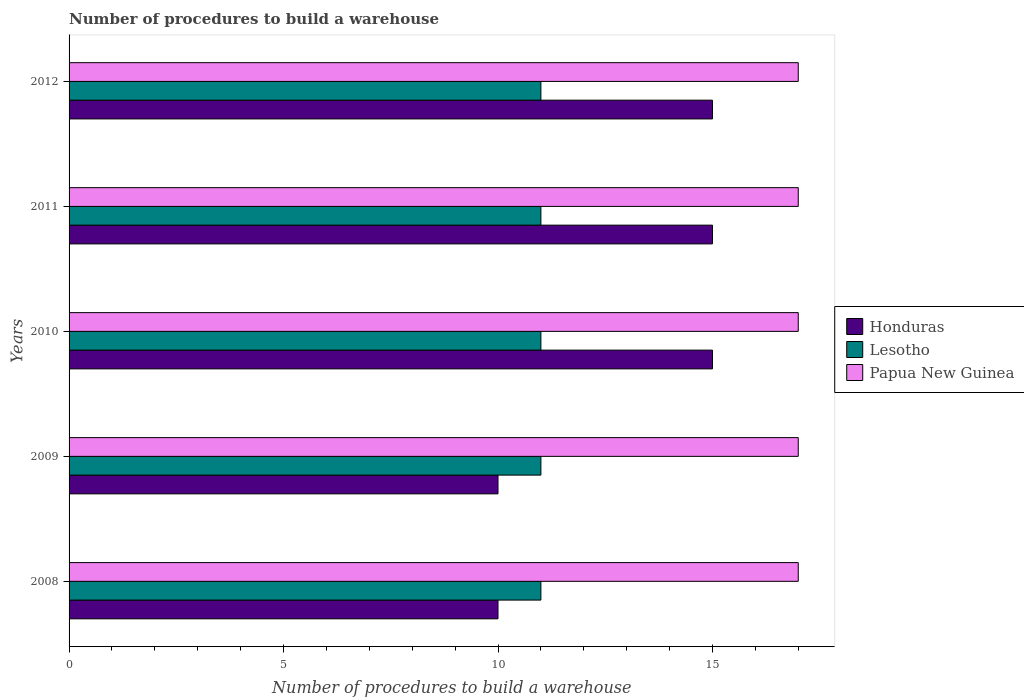How many groups of bars are there?
Ensure brevity in your answer.  5. Are the number of bars per tick equal to the number of legend labels?
Your answer should be very brief. Yes. What is the label of the 2nd group of bars from the top?
Provide a short and direct response. 2011. In how many cases, is the number of bars for a given year not equal to the number of legend labels?
Offer a terse response. 0. What is the number of procedures to build a warehouse in in Honduras in 2011?
Make the answer very short. 15. Across all years, what is the maximum number of procedures to build a warehouse in in Honduras?
Provide a short and direct response. 15. Across all years, what is the minimum number of procedures to build a warehouse in in Lesotho?
Provide a succinct answer. 11. In which year was the number of procedures to build a warehouse in in Papua New Guinea maximum?
Ensure brevity in your answer.  2008. What is the total number of procedures to build a warehouse in in Lesotho in the graph?
Offer a very short reply. 55. What is the difference between the number of procedures to build a warehouse in in Lesotho in 2008 and that in 2012?
Offer a very short reply. 0. What is the difference between the number of procedures to build a warehouse in in Lesotho in 2009 and the number of procedures to build a warehouse in in Papua New Guinea in 2011?
Provide a succinct answer. -6. In the year 2011, what is the difference between the number of procedures to build a warehouse in in Lesotho and number of procedures to build a warehouse in in Honduras?
Give a very brief answer. -4. In how many years, is the number of procedures to build a warehouse in in Papua New Guinea greater than 9 ?
Provide a succinct answer. 5. Is the number of procedures to build a warehouse in in Lesotho in 2010 less than that in 2011?
Provide a succinct answer. No. Is the difference between the number of procedures to build a warehouse in in Lesotho in 2010 and 2011 greater than the difference between the number of procedures to build a warehouse in in Honduras in 2010 and 2011?
Provide a short and direct response. No. What is the difference between the highest and the lowest number of procedures to build a warehouse in in Lesotho?
Your answer should be very brief. 0. Is the sum of the number of procedures to build a warehouse in in Papua New Guinea in 2008 and 2009 greater than the maximum number of procedures to build a warehouse in in Honduras across all years?
Your response must be concise. Yes. What does the 1st bar from the top in 2012 represents?
Your answer should be very brief. Papua New Guinea. What does the 2nd bar from the bottom in 2010 represents?
Your answer should be very brief. Lesotho. How many years are there in the graph?
Provide a succinct answer. 5. Are the values on the major ticks of X-axis written in scientific E-notation?
Your response must be concise. No. Does the graph contain any zero values?
Offer a very short reply. No. Where does the legend appear in the graph?
Ensure brevity in your answer.  Center right. What is the title of the graph?
Your answer should be very brief. Number of procedures to build a warehouse. What is the label or title of the X-axis?
Your response must be concise. Number of procedures to build a warehouse. What is the label or title of the Y-axis?
Provide a succinct answer. Years. What is the Number of procedures to build a warehouse of Papua New Guinea in 2008?
Offer a very short reply. 17. What is the Number of procedures to build a warehouse of Honduras in 2009?
Your answer should be compact. 10. What is the Number of procedures to build a warehouse of Lesotho in 2010?
Offer a terse response. 11. What is the Number of procedures to build a warehouse in Papua New Guinea in 2010?
Provide a succinct answer. 17. What is the Number of procedures to build a warehouse in Honduras in 2011?
Offer a very short reply. 15. What is the Number of procedures to build a warehouse of Lesotho in 2011?
Offer a terse response. 11. What is the Number of procedures to build a warehouse of Papua New Guinea in 2012?
Make the answer very short. 17. Across all years, what is the maximum Number of procedures to build a warehouse in Lesotho?
Your answer should be very brief. 11. Across all years, what is the maximum Number of procedures to build a warehouse in Papua New Guinea?
Offer a terse response. 17. Across all years, what is the minimum Number of procedures to build a warehouse in Lesotho?
Your response must be concise. 11. What is the total Number of procedures to build a warehouse in Honduras in the graph?
Offer a terse response. 65. What is the difference between the Number of procedures to build a warehouse in Lesotho in 2008 and that in 2009?
Your answer should be very brief. 0. What is the difference between the Number of procedures to build a warehouse of Papua New Guinea in 2008 and that in 2009?
Your answer should be compact. 0. What is the difference between the Number of procedures to build a warehouse of Honduras in 2008 and that in 2010?
Give a very brief answer. -5. What is the difference between the Number of procedures to build a warehouse in Papua New Guinea in 2008 and that in 2010?
Make the answer very short. 0. What is the difference between the Number of procedures to build a warehouse in Honduras in 2008 and that in 2011?
Your answer should be compact. -5. What is the difference between the Number of procedures to build a warehouse in Lesotho in 2008 and that in 2011?
Offer a very short reply. 0. What is the difference between the Number of procedures to build a warehouse in Papua New Guinea in 2008 and that in 2011?
Ensure brevity in your answer.  0. What is the difference between the Number of procedures to build a warehouse of Honduras in 2009 and that in 2010?
Make the answer very short. -5. What is the difference between the Number of procedures to build a warehouse in Papua New Guinea in 2009 and that in 2012?
Provide a short and direct response. 0. What is the difference between the Number of procedures to build a warehouse in Lesotho in 2010 and that in 2012?
Offer a very short reply. 0. What is the difference between the Number of procedures to build a warehouse in Papua New Guinea in 2010 and that in 2012?
Give a very brief answer. 0. What is the difference between the Number of procedures to build a warehouse in Lesotho in 2011 and that in 2012?
Offer a very short reply. 0. What is the difference between the Number of procedures to build a warehouse of Papua New Guinea in 2011 and that in 2012?
Make the answer very short. 0. What is the difference between the Number of procedures to build a warehouse in Honduras in 2008 and the Number of procedures to build a warehouse in Lesotho in 2009?
Your answer should be very brief. -1. What is the difference between the Number of procedures to build a warehouse of Honduras in 2008 and the Number of procedures to build a warehouse of Papua New Guinea in 2009?
Offer a very short reply. -7. What is the difference between the Number of procedures to build a warehouse of Honduras in 2008 and the Number of procedures to build a warehouse of Papua New Guinea in 2010?
Your answer should be very brief. -7. What is the difference between the Number of procedures to build a warehouse of Lesotho in 2008 and the Number of procedures to build a warehouse of Papua New Guinea in 2010?
Your answer should be compact. -6. What is the difference between the Number of procedures to build a warehouse of Honduras in 2008 and the Number of procedures to build a warehouse of Lesotho in 2011?
Your answer should be very brief. -1. What is the difference between the Number of procedures to build a warehouse in Honduras in 2008 and the Number of procedures to build a warehouse in Papua New Guinea in 2011?
Provide a short and direct response. -7. What is the difference between the Number of procedures to build a warehouse in Honduras in 2009 and the Number of procedures to build a warehouse in Papua New Guinea in 2010?
Provide a succinct answer. -7. What is the difference between the Number of procedures to build a warehouse of Lesotho in 2009 and the Number of procedures to build a warehouse of Papua New Guinea in 2010?
Make the answer very short. -6. What is the difference between the Number of procedures to build a warehouse of Honduras in 2009 and the Number of procedures to build a warehouse of Lesotho in 2011?
Offer a very short reply. -1. What is the difference between the Number of procedures to build a warehouse of Honduras in 2009 and the Number of procedures to build a warehouse of Papua New Guinea in 2011?
Ensure brevity in your answer.  -7. What is the difference between the Number of procedures to build a warehouse in Honduras in 2009 and the Number of procedures to build a warehouse in Lesotho in 2012?
Your answer should be compact. -1. What is the difference between the Number of procedures to build a warehouse in Lesotho in 2009 and the Number of procedures to build a warehouse in Papua New Guinea in 2012?
Make the answer very short. -6. What is the difference between the Number of procedures to build a warehouse in Honduras in 2010 and the Number of procedures to build a warehouse in Lesotho in 2012?
Keep it short and to the point. 4. What is the difference between the Number of procedures to build a warehouse in Honduras in 2011 and the Number of procedures to build a warehouse in Lesotho in 2012?
Your answer should be compact. 4. What is the difference between the Number of procedures to build a warehouse of Lesotho in 2011 and the Number of procedures to build a warehouse of Papua New Guinea in 2012?
Offer a very short reply. -6. What is the average Number of procedures to build a warehouse in Honduras per year?
Provide a short and direct response. 13. In the year 2008, what is the difference between the Number of procedures to build a warehouse in Honduras and Number of procedures to build a warehouse in Papua New Guinea?
Your answer should be very brief. -7. In the year 2009, what is the difference between the Number of procedures to build a warehouse in Honduras and Number of procedures to build a warehouse in Lesotho?
Make the answer very short. -1. In the year 2010, what is the difference between the Number of procedures to build a warehouse of Honduras and Number of procedures to build a warehouse of Lesotho?
Your answer should be very brief. 4. In the year 2010, what is the difference between the Number of procedures to build a warehouse of Lesotho and Number of procedures to build a warehouse of Papua New Guinea?
Your response must be concise. -6. In the year 2011, what is the difference between the Number of procedures to build a warehouse in Honduras and Number of procedures to build a warehouse in Lesotho?
Ensure brevity in your answer.  4. In the year 2011, what is the difference between the Number of procedures to build a warehouse of Honduras and Number of procedures to build a warehouse of Papua New Guinea?
Make the answer very short. -2. In the year 2012, what is the difference between the Number of procedures to build a warehouse of Honduras and Number of procedures to build a warehouse of Papua New Guinea?
Provide a short and direct response. -2. In the year 2012, what is the difference between the Number of procedures to build a warehouse in Lesotho and Number of procedures to build a warehouse in Papua New Guinea?
Keep it short and to the point. -6. What is the ratio of the Number of procedures to build a warehouse of Honduras in 2008 to that in 2009?
Ensure brevity in your answer.  1. What is the ratio of the Number of procedures to build a warehouse in Papua New Guinea in 2008 to that in 2009?
Your answer should be very brief. 1. What is the ratio of the Number of procedures to build a warehouse in Lesotho in 2008 to that in 2010?
Give a very brief answer. 1. What is the ratio of the Number of procedures to build a warehouse of Papua New Guinea in 2008 to that in 2010?
Your response must be concise. 1. What is the ratio of the Number of procedures to build a warehouse in Honduras in 2008 to that in 2011?
Make the answer very short. 0.67. What is the ratio of the Number of procedures to build a warehouse of Papua New Guinea in 2008 to that in 2011?
Offer a very short reply. 1. What is the ratio of the Number of procedures to build a warehouse of Lesotho in 2008 to that in 2012?
Your answer should be very brief. 1. What is the ratio of the Number of procedures to build a warehouse of Honduras in 2009 to that in 2010?
Offer a terse response. 0.67. What is the ratio of the Number of procedures to build a warehouse of Lesotho in 2009 to that in 2010?
Make the answer very short. 1. What is the ratio of the Number of procedures to build a warehouse of Papua New Guinea in 2009 to that in 2011?
Keep it short and to the point. 1. What is the ratio of the Number of procedures to build a warehouse of Papua New Guinea in 2009 to that in 2012?
Your answer should be compact. 1. What is the ratio of the Number of procedures to build a warehouse in Honduras in 2010 to that in 2011?
Provide a short and direct response. 1. What is the ratio of the Number of procedures to build a warehouse of Honduras in 2010 to that in 2012?
Your answer should be very brief. 1. What is the ratio of the Number of procedures to build a warehouse of Lesotho in 2010 to that in 2012?
Your response must be concise. 1. What is the ratio of the Number of procedures to build a warehouse of Papua New Guinea in 2010 to that in 2012?
Ensure brevity in your answer.  1. What is the ratio of the Number of procedures to build a warehouse of Lesotho in 2011 to that in 2012?
Your response must be concise. 1. What is the ratio of the Number of procedures to build a warehouse of Papua New Guinea in 2011 to that in 2012?
Provide a short and direct response. 1. What is the difference between the highest and the second highest Number of procedures to build a warehouse of Honduras?
Your response must be concise. 0. What is the difference between the highest and the second highest Number of procedures to build a warehouse in Papua New Guinea?
Ensure brevity in your answer.  0. What is the difference between the highest and the lowest Number of procedures to build a warehouse of Lesotho?
Your answer should be very brief. 0. What is the difference between the highest and the lowest Number of procedures to build a warehouse of Papua New Guinea?
Your response must be concise. 0. 